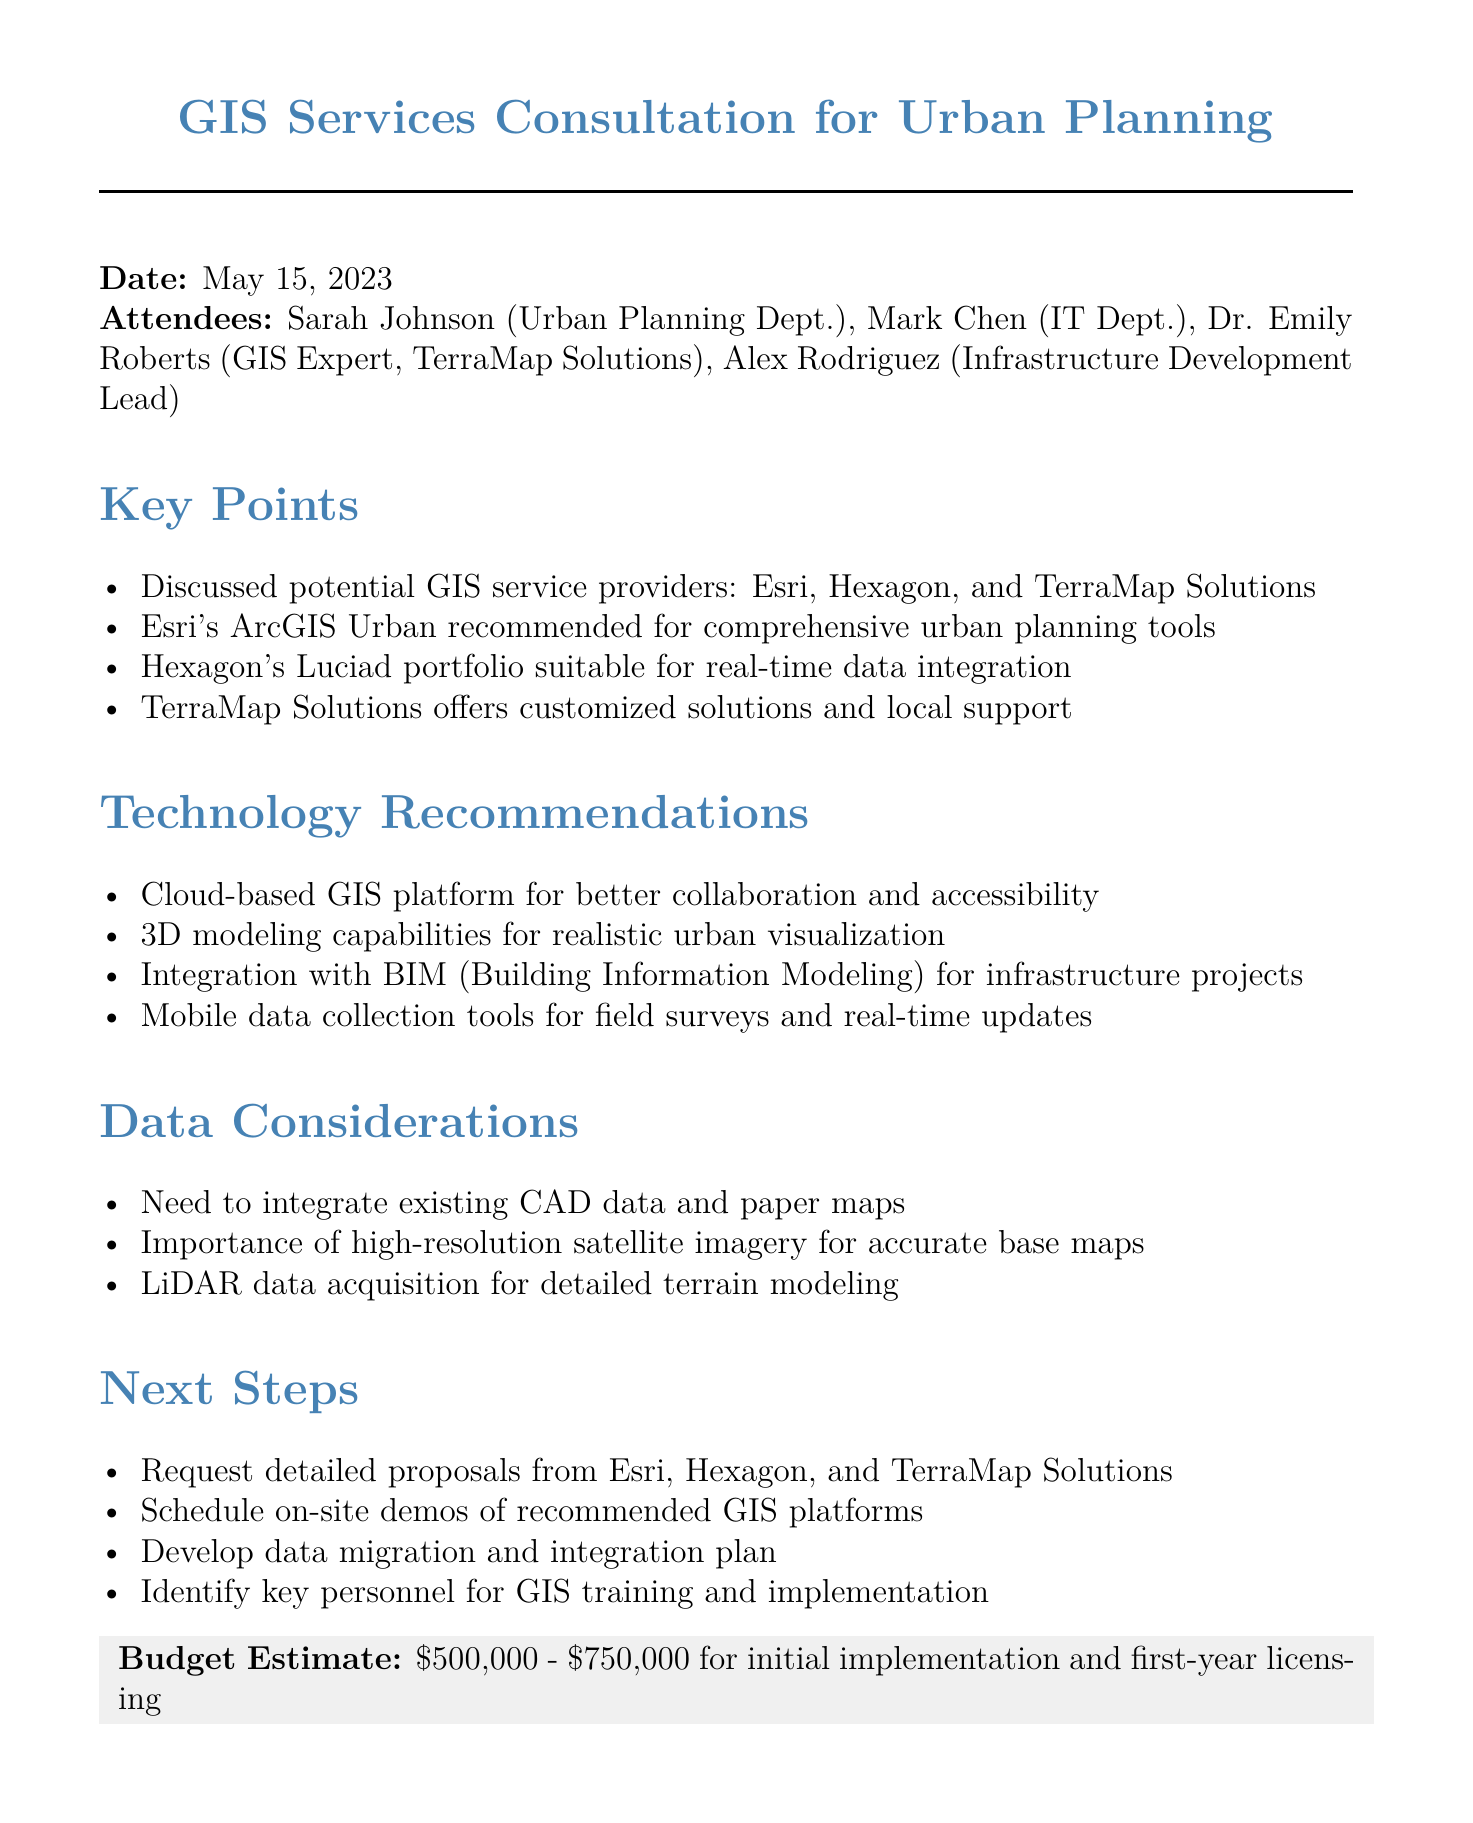What is the title of the meeting? The title of the meeting is stated at the beginning of the document.
Answer: GIS Services Consultation for Urban Planning Who is in charge of the Urban Planning Department? The attendees section lists Sarah Johnson as representing the Urban Planning Department.
Answer: Sarah Johnson What date was the meeting held? The date of the meeting is explicitly mentioned in the document.
Answer: May 15, 2023 Which GIS service provider is recommended for comprehensive urban planning tools? The key points summarize the recommendations made during the meeting.
Answer: Esri What is the budget estimate for initial implementation and first-year licensing? The budget estimate is clearly stated in the document.
Answer: $500,000 - $750,000 What technology was highlighted for realistic urban visualization? The technology recommendations list includes this specific capability.
Answer: 3D modeling capabilities What should be developed after receiving proposals from GIS service providers? The next steps include a strategy after receiving proposals.
Answer: Data migration and integration plan Which data needs to be integrated according to the data considerations? A specific type of data that requires integration is mentioned.
Answer: Existing CAD data and paper maps Who is Dr. Emily Roberts? The context provides her role in the meeting, indicating her professional background.
Answer: GIS Expert, TerraMap Solutions What kind of demos should be scheduled as part of the next steps? The next steps outline what should be organized following the meeting.
Answer: On-site demos of recommended GIS platforms 